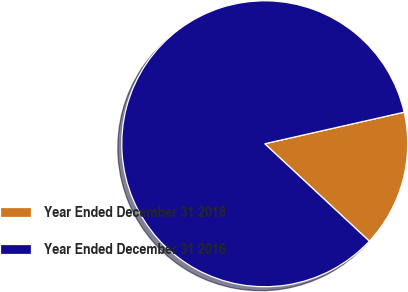<chart> <loc_0><loc_0><loc_500><loc_500><pie_chart><fcel>Year Ended December 31 2018<fcel>Year Ended December 31 2016<nl><fcel>15.48%<fcel>84.52%<nl></chart> 